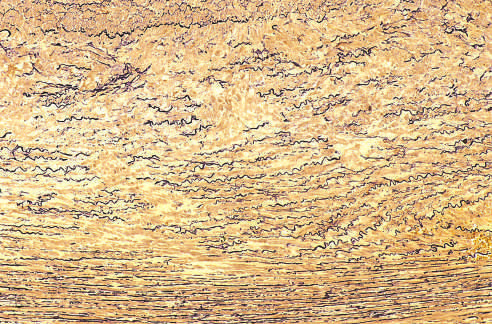what did the cross-section of aortic media from a patient with marfan syndrome show?
Answer the question using a single word or phrase. Marked elastin fragmentation and areas devoid of elastin that resemble cystic spaces 